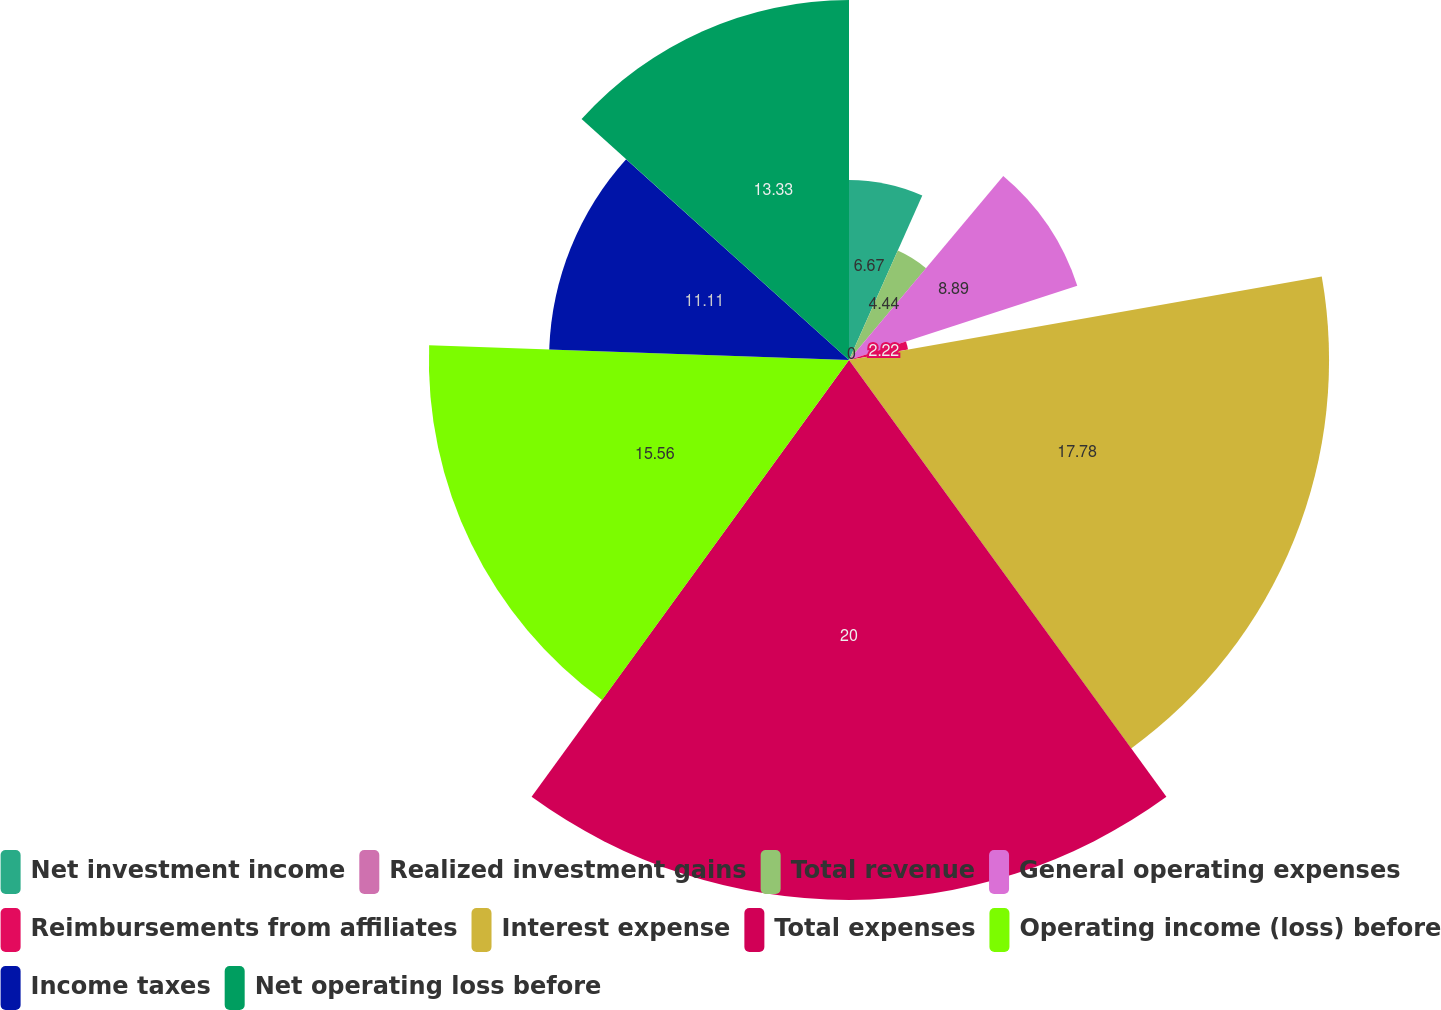<chart> <loc_0><loc_0><loc_500><loc_500><pie_chart><fcel>Net investment income<fcel>Realized investment gains<fcel>Total revenue<fcel>General operating expenses<fcel>Reimbursements from affiliates<fcel>Interest expense<fcel>Total expenses<fcel>Operating income (loss) before<fcel>Income taxes<fcel>Net operating loss before<nl><fcel>6.67%<fcel>0.0%<fcel>4.44%<fcel>8.89%<fcel>2.22%<fcel>17.78%<fcel>20.0%<fcel>15.56%<fcel>11.11%<fcel>13.33%<nl></chart> 